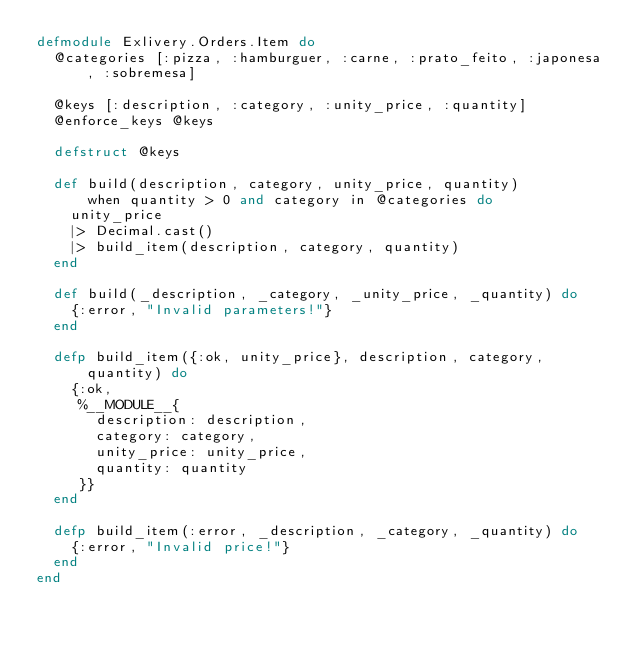<code> <loc_0><loc_0><loc_500><loc_500><_Elixir_>defmodule Exlivery.Orders.Item do
  @categories [:pizza, :hamburguer, :carne, :prato_feito, :japonesa, :sobremesa]

  @keys [:description, :category, :unity_price, :quantity]
  @enforce_keys @keys

  defstruct @keys

  def build(description, category, unity_price, quantity)
      when quantity > 0 and category in @categories do
    unity_price
    |> Decimal.cast()
    |> build_item(description, category, quantity)
  end

  def build(_description, _category, _unity_price, _quantity) do
    {:error, "Invalid parameters!"}
  end

  defp build_item({:ok, unity_price}, description, category, quantity) do
    {:ok,
     %__MODULE__{
       description: description,
       category: category,
       unity_price: unity_price,
       quantity: quantity
     }}
  end

  defp build_item(:error, _description, _category, _quantity) do
    {:error, "Invalid price!"}
  end
end
</code> 